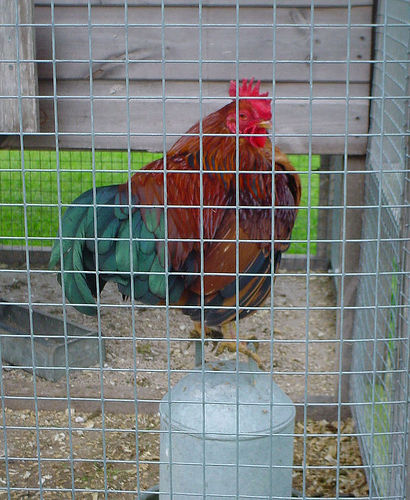<image>
Is the chicken under the cage? Yes. The chicken is positioned underneath the cage, with the cage above it in the vertical space. Is the rooster in the ground? No. The rooster is not contained within the ground. These objects have a different spatial relationship. 